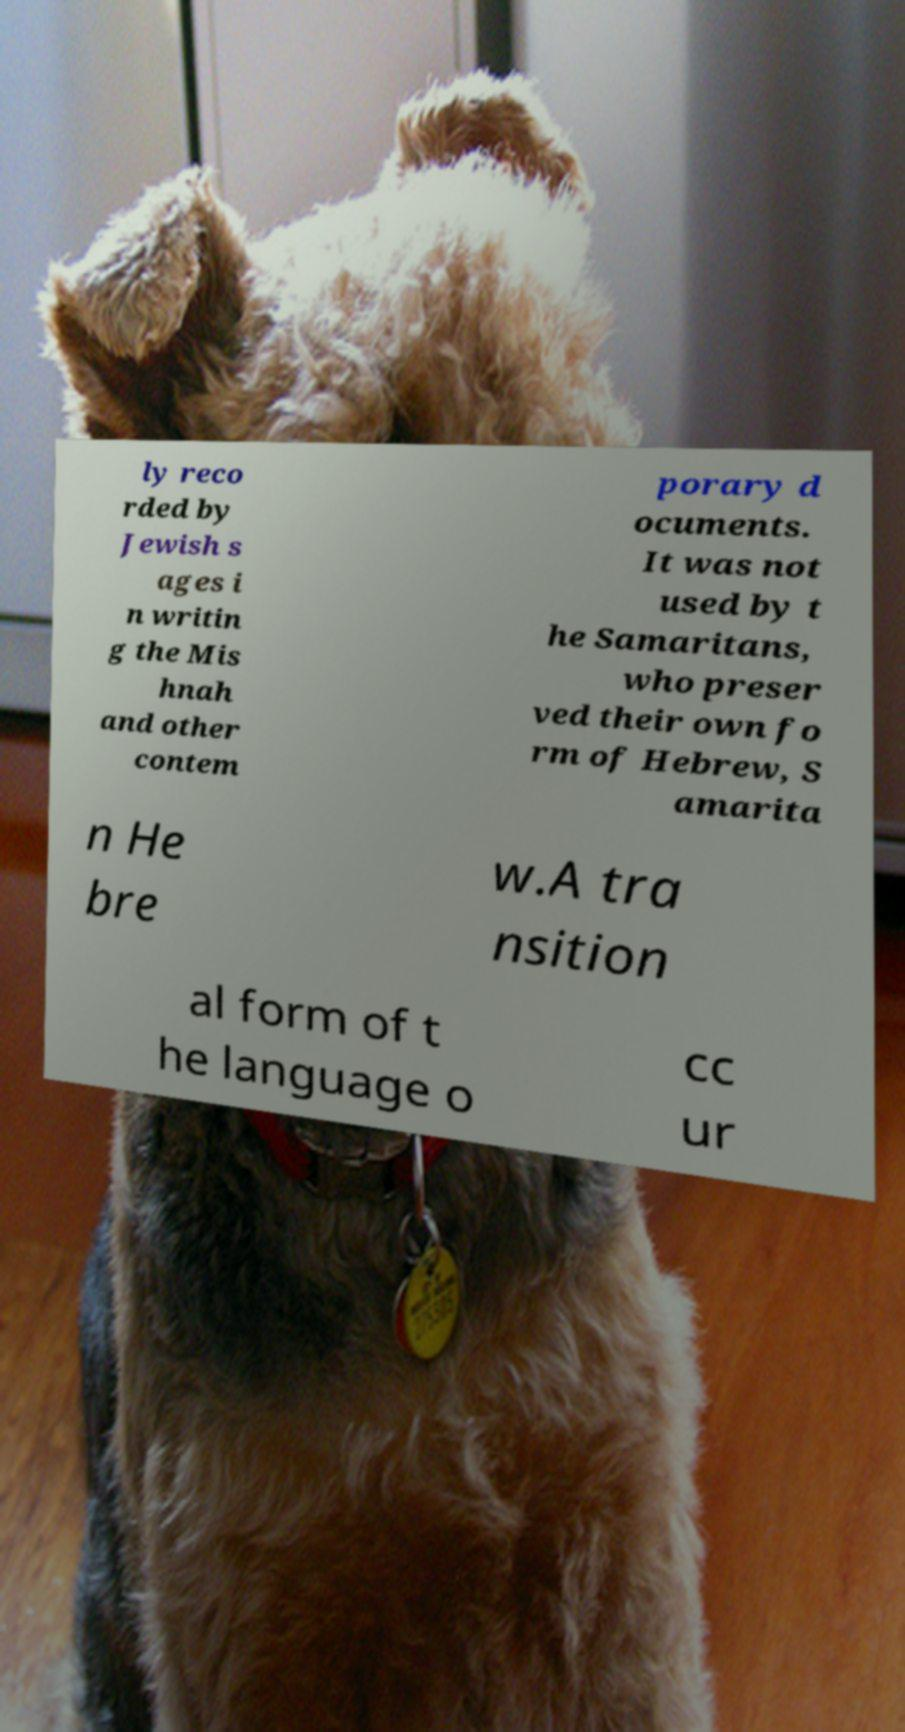Could you extract and type out the text from this image? ly reco rded by Jewish s ages i n writin g the Mis hnah and other contem porary d ocuments. It was not used by t he Samaritans, who preser ved their own fo rm of Hebrew, S amarita n He bre w.A tra nsition al form of t he language o cc ur 